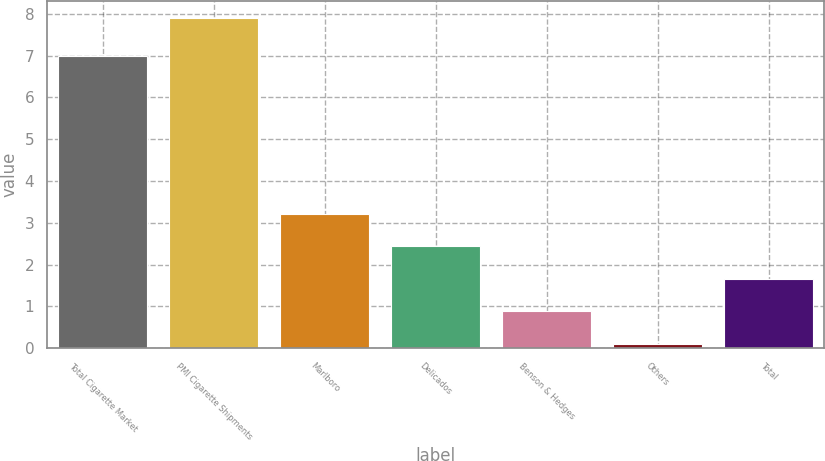Convert chart. <chart><loc_0><loc_0><loc_500><loc_500><bar_chart><fcel>Total Cigarette Market<fcel>PMI Cigarette Shipments<fcel>Marlboro<fcel>Delicados<fcel>Benson & Hedges<fcel>Others<fcel>Total<nl><fcel>7<fcel>7.9<fcel>3.22<fcel>2.44<fcel>0.88<fcel>0.1<fcel>1.66<nl></chart> 